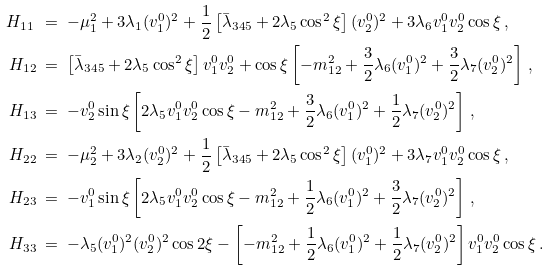Convert formula to latex. <formula><loc_0><loc_0><loc_500><loc_500>H _ { 1 1 } \ & = \ - \mu _ { 1 } ^ { 2 } + 3 \lambda _ { 1 } ( v _ { 1 } ^ { 0 } ) ^ { 2 } + \frac { 1 } { 2 } \left [ \bar { \lambda } _ { 3 4 5 } + 2 \lambda _ { 5 } \cos ^ { 2 } \xi \right ] ( v _ { 2 } ^ { 0 } ) ^ { 2 } + 3 \lambda _ { 6 } v _ { 1 } ^ { 0 } v _ { 2 } ^ { 0 } \cos \xi \, , \\ H _ { 1 2 } \ & = \ \left [ \bar { \lambda } _ { 3 4 5 } + 2 \lambda _ { 5 } \cos ^ { 2 } \xi \right ] v _ { 1 } ^ { 0 } v _ { 2 } ^ { 0 } + \cos \xi \left [ - m _ { 1 2 } ^ { 2 } + \frac { 3 } { 2 } \lambda _ { 6 } ( v _ { 1 } ^ { 0 } ) ^ { 2 } + \frac { 3 } { 2 } \lambda _ { 7 } ( v _ { 2 } ^ { 0 } ) ^ { 2 } \right ] \, , \\ H _ { 1 3 } \ & = \ - v _ { 2 } ^ { 0 } \sin \xi \left [ 2 \lambda _ { 5 } v _ { 1 } ^ { 0 } v _ { 2 } ^ { 0 } \cos \xi - m _ { 1 2 } ^ { 2 } + \frac { 3 } { 2 } \lambda _ { 6 } ( v _ { 1 } ^ { 0 } ) ^ { 2 } + \frac { 1 } { 2 } \lambda _ { 7 } ( v _ { 2 } ^ { 0 } ) ^ { 2 } \right ] \, , \\ H _ { 2 2 } \ & = \ - \mu _ { 2 } ^ { 2 } + 3 \lambda _ { 2 } ( v _ { 2 } ^ { 0 } ) ^ { 2 } + \frac { 1 } { 2 } \left [ \bar { \lambda } _ { 3 4 5 } + 2 \lambda _ { 5 } \cos ^ { 2 } \xi \right ] ( v _ { 1 } ^ { 0 } ) ^ { 2 } + 3 \lambda _ { 7 } v _ { 1 } ^ { 0 } v _ { 2 } ^ { 0 } \cos \xi \, , \\ H _ { 2 3 } \ & = \ - v _ { 1 } ^ { 0 } \sin \xi \left [ 2 \lambda _ { 5 } v _ { 1 } ^ { 0 } v _ { 2 } ^ { 0 } \cos \xi - m _ { 1 2 } ^ { 2 } + \frac { 1 } { 2 } \lambda _ { 6 } ( v _ { 1 } ^ { 0 } ) ^ { 2 } + \frac { 3 } { 2 } \lambda _ { 7 } ( v _ { 2 } ^ { 0 } ) ^ { 2 } \right ] \, , \\ H _ { 3 3 } \ & = \ - \lambda _ { 5 } ( v _ { 1 } ^ { 0 } ) ^ { 2 } ( v _ { 2 } ^ { 0 } ) ^ { 2 } \cos 2 \xi - \left [ - m _ { 1 2 } ^ { 2 } + \frac { 1 } { 2 } \lambda _ { 6 } ( v _ { 1 } ^ { 0 } ) ^ { 2 } + \frac { 1 } { 2 } \lambda _ { 7 } ( v _ { 2 } ^ { 0 } ) ^ { 2 } \right ] v _ { 1 } ^ { 0 } v _ { 2 } ^ { 0 } \cos \xi \, .</formula> 